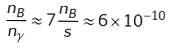<formula> <loc_0><loc_0><loc_500><loc_500>\frac { n _ { B } } { n _ { \gamma } } \approx 7 \frac { n _ { B } } { s } \approx 6 \times 1 0 ^ { - 1 0 }</formula> 